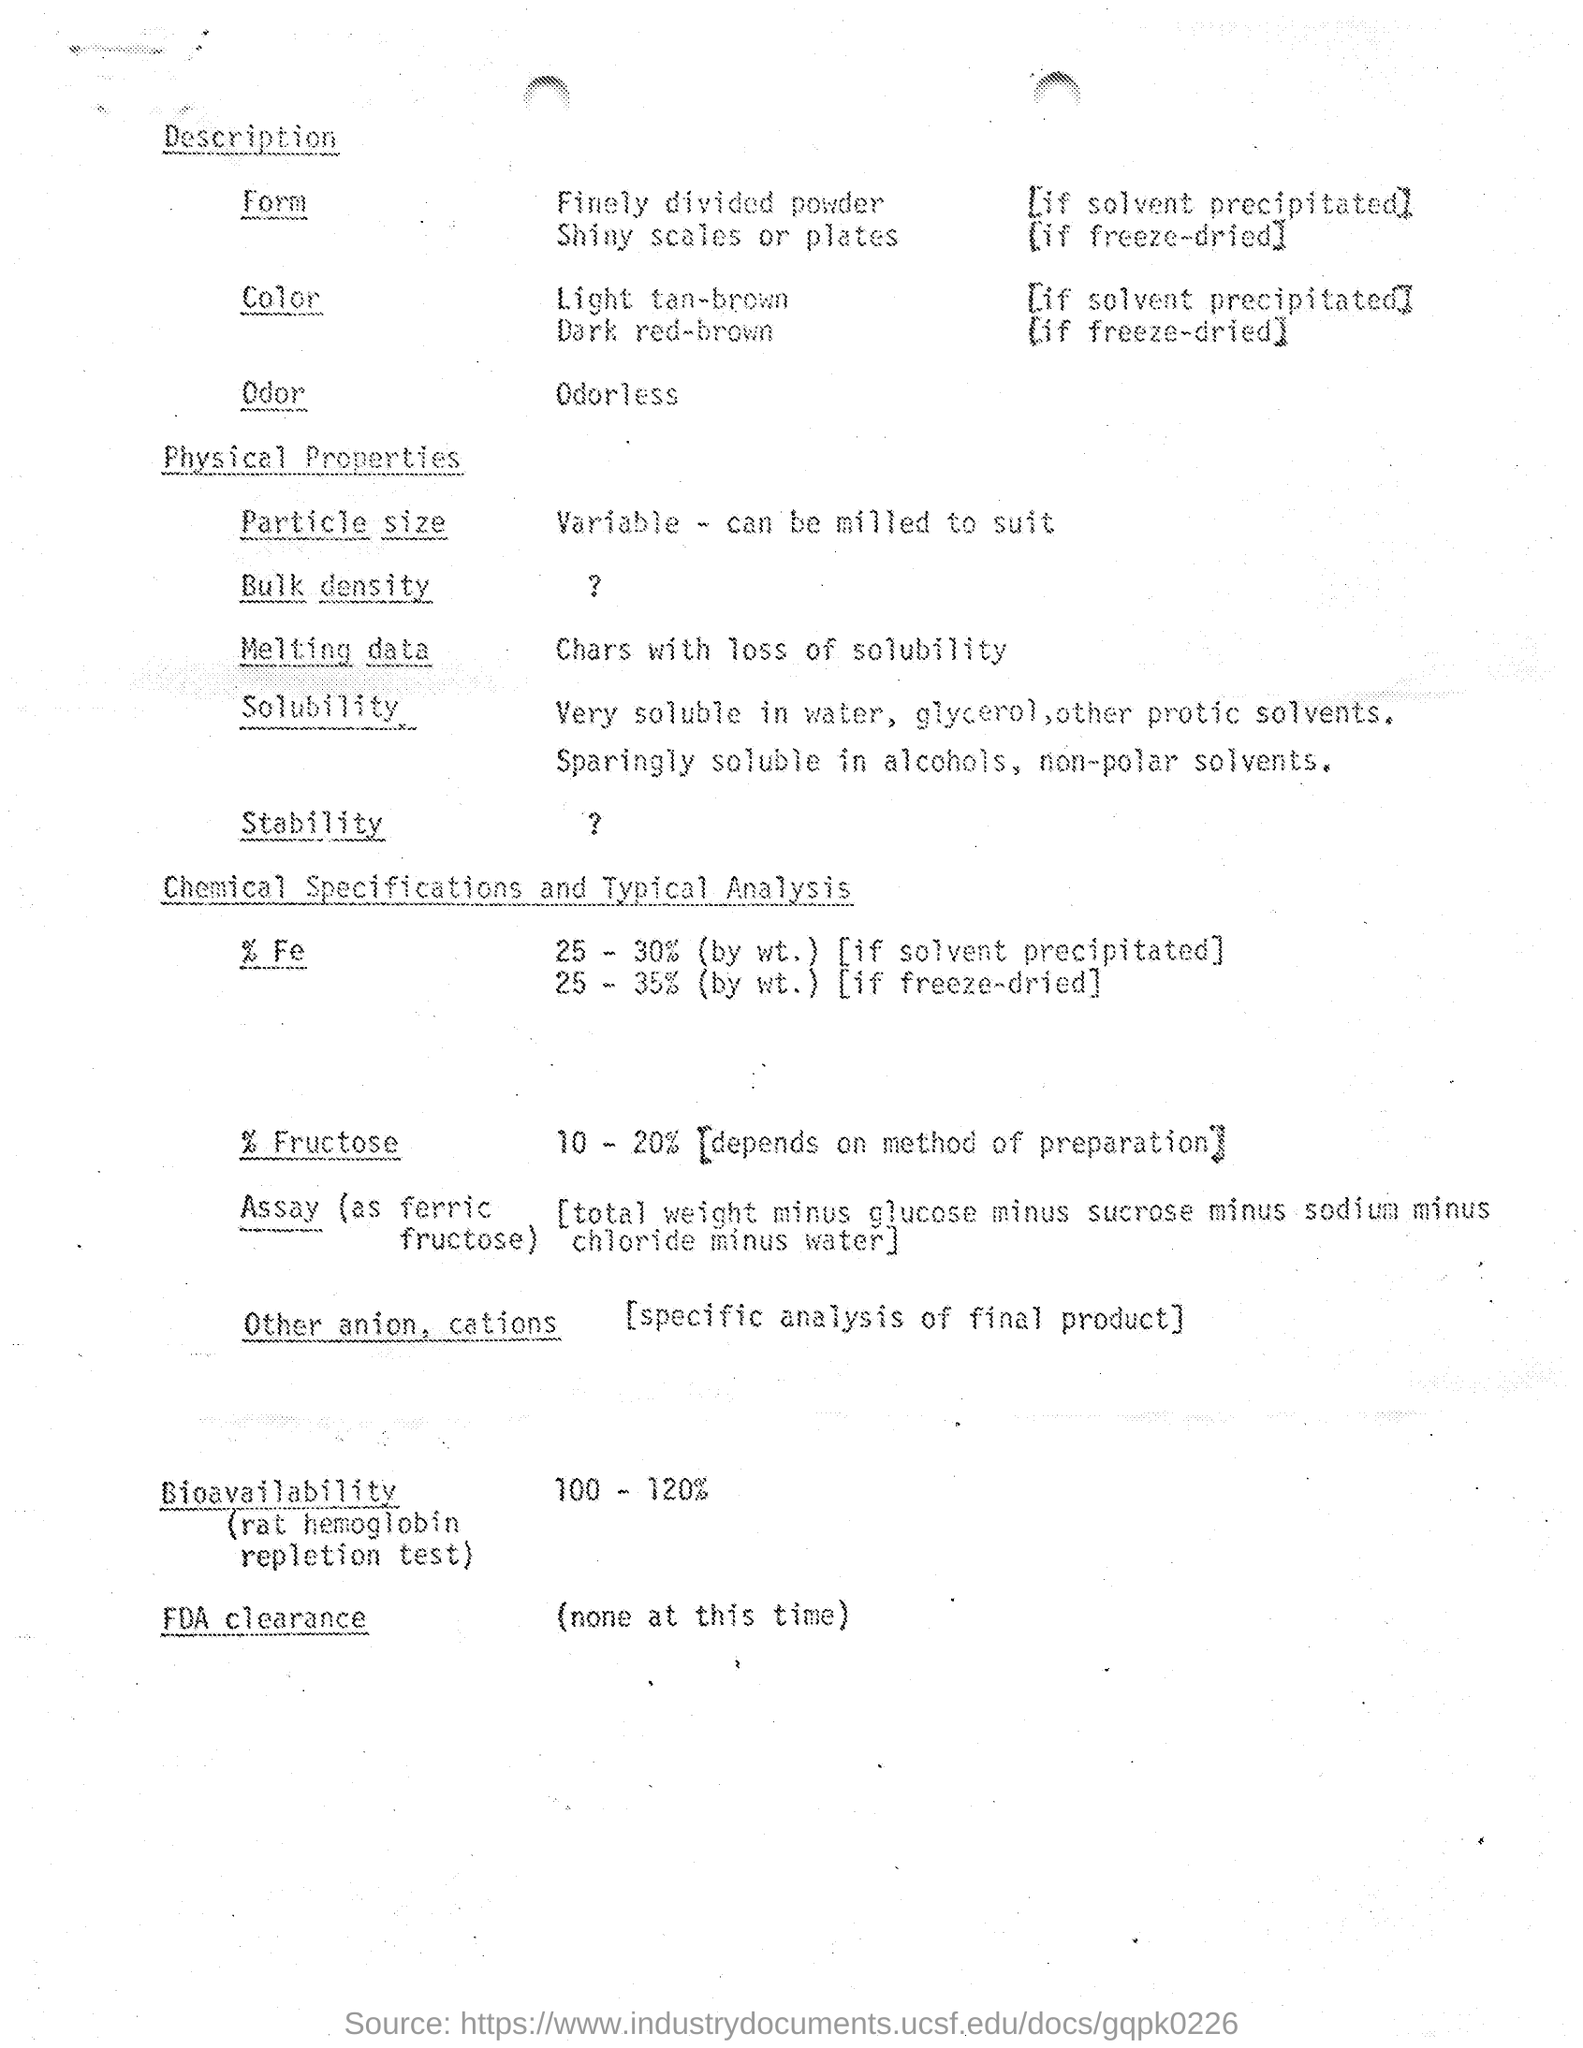What is the Odor?
Offer a terse response. Odorless. What is the color, if solvent precipitated?
Your answer should be compact. Light tan-brown. What is the color, if freeze-dried?
Offer a terse response. Dark red-brown. In which form, if solvent precipitated?
Offer a terse response. Finely divided powder. In which form, if freeze-dried?
Provide a short and direct response. Shiny scales or plates. 